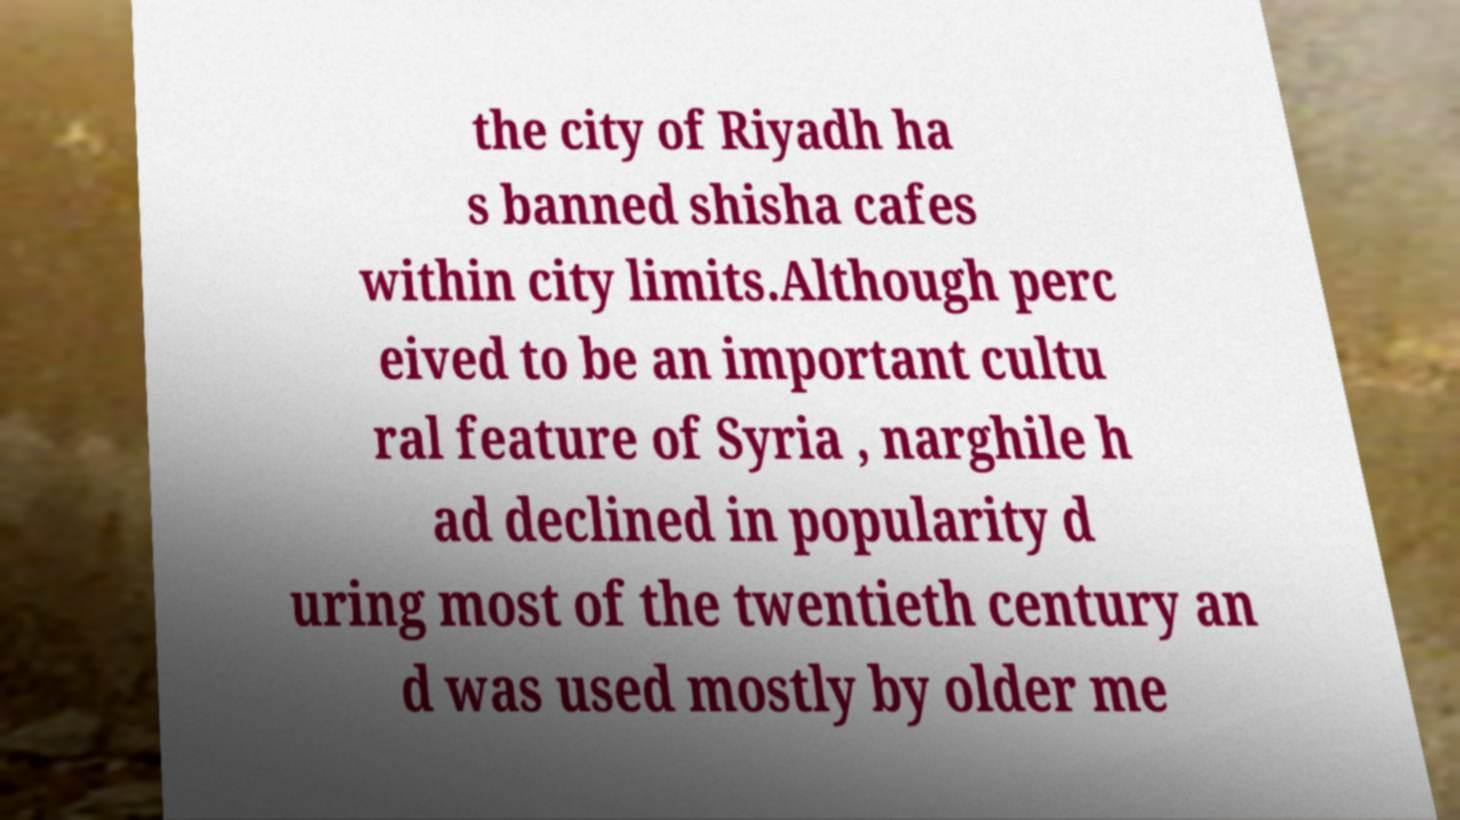There's text embedded in this image that I need extracted. Can you transcribe it verbatim? the city of Riyadh ha s banned shisha cafes within city limits.Although perc eived to be an important cultu ral feature of Syria , narghile h ad declined in popularity d uring most of the twentieth century an d was used mostly by older me 